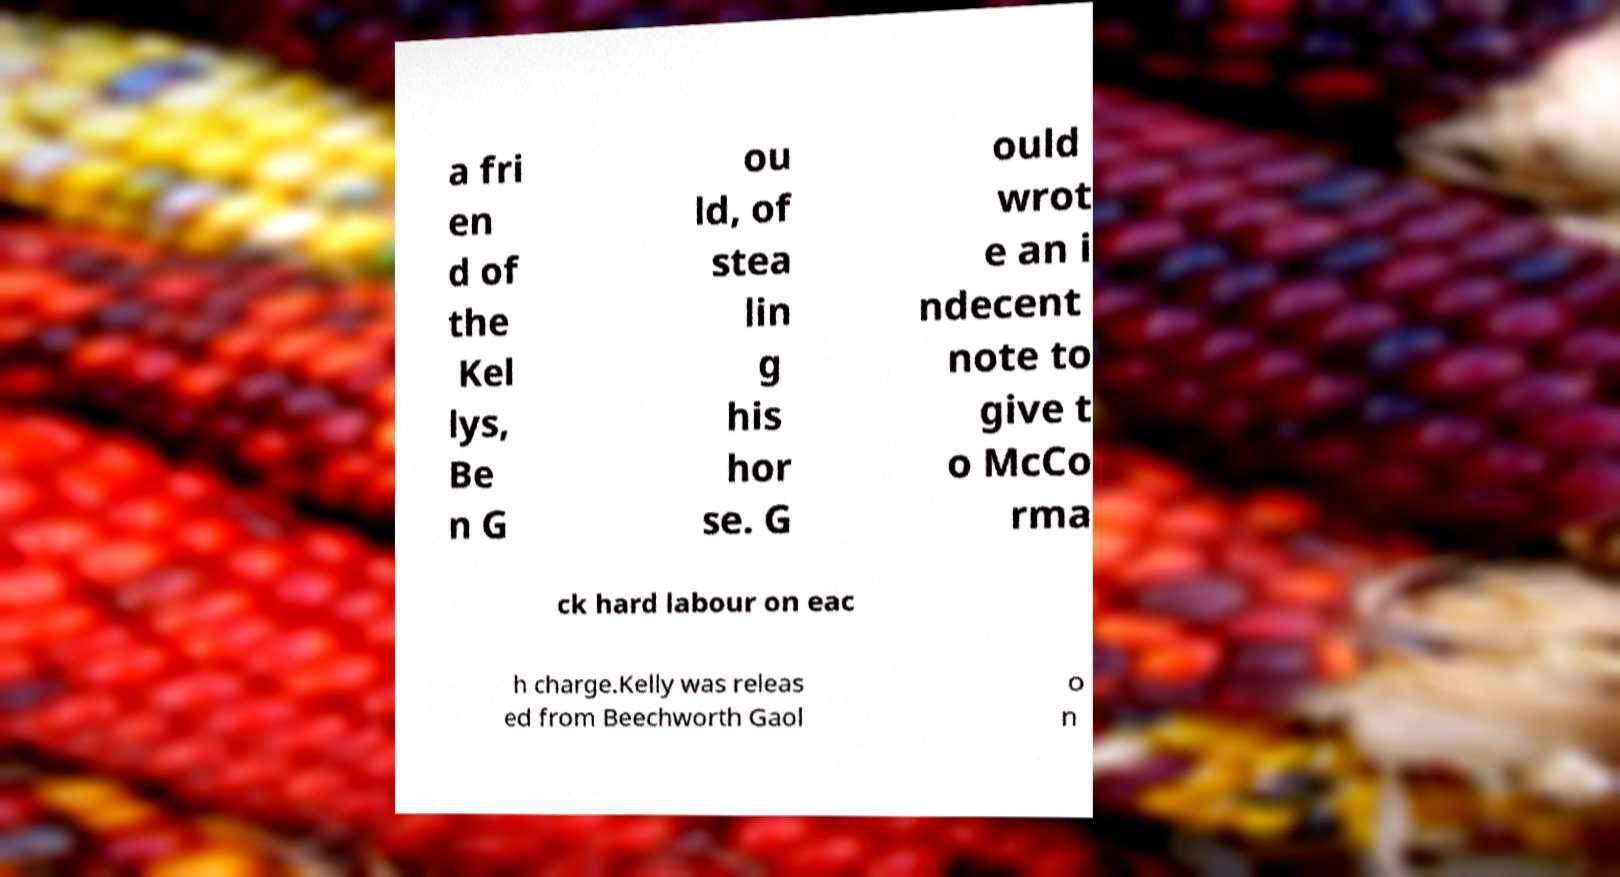Please identify and transcribe the text found in this image. a fri en d of the Kel lys, Be n G ou ld, of stea lin g his hor se. G ould wrot e an i ndecent note to give t o McCo rma ck hard labour on eac h charge.Kelly was releas ed from Beechworth Gaol o n 